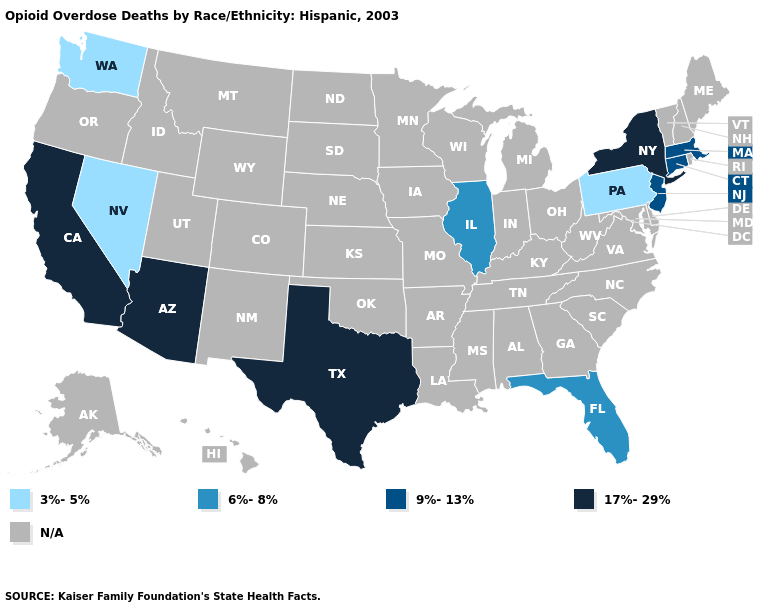Is the legend a continuous bar?
Quick response, please. No. What is the highest value in the USA?
Concise answer only. 17%-29%. What is the value of Iowa?
Quick response, please. N/A. Does New York have the highest value in the Northeast?
Answer briefly. Yes. Name the states that have a value in the range 9%-13%?
Write a very short answer. Connecticut, Massachusetts, New Jersey. Does the first symbol in the legend represent the smallest category?
Write a very short answer. Yes. Name the states that have a value in the range N/A?
Concise answer only. Alabama, Alaska, Arkansas, Colorado, Delaware, Georgia, Hawaii, Idaho, Indiana, Iowa, Kansas, Kentucky, Louisiana, Maine, Maryland, Michigan, Minnesota, Mississippi, Missouri, Montana, Nebraska, New Hampshire, New Mexico, North Carolina, North Dakota, Ohio, Oklahoma, Oregon, Rhode Island, South Carolina, South Dakota, Tennessee, Utah, Vermont, Virginia, West Virginia, Wisconsin, Wyoming. Name the states that have a value in the range N/A?
Write a very short answer. Alabama, Alaska, Arkansas, Colorado, Delaware, Georgia, Hawaii, Idaho, Indiana, Iowa, Kansas, Kentucky, Louisiana, Maine, Maryland, Michigan, Minnesota, Mississippi, Missouri, Montana, Nebraska, New Hampshire, New Mexico, North Carolina, North Dakota, Ohio, Oklahoma, Oregon, Rhode Island, South Carolina, South Dakota, Tennessee, Utah, Vermont, Virginia, West Virginia, Wisconsin, Wyoming. Is the legend a continuous bar?
Keep it brief. No. Among the states that border Arizona , which have the lowest value?
Be succinct. Nevada. Is the legend a continuous bar?
Be succinct. No. Among the states that border Ohio , which have the lowest value?
Keep it brief. Pennsylvania. Which states have the lowest value in the MidWest?
Short answer required. Illinois. What is the lowest value in the USA?
Answer briefly. 3%-5%. Name the states that have a value in the range 6%-8%?
Concise answer only. Florida, Illinois. 